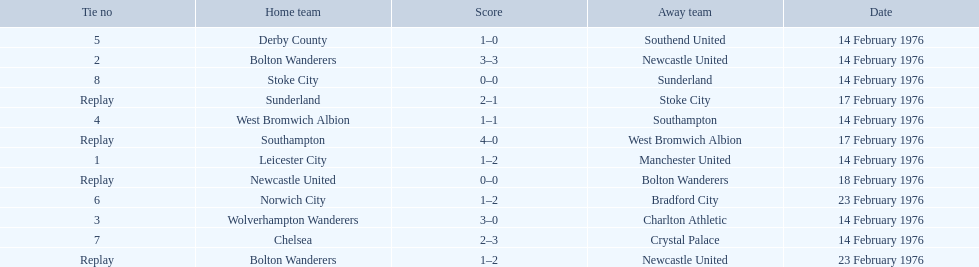What are all of the scores of the 1975-76 fa cup? 1–2, 3–3, 0–0, 1–2, 3–0, 1–1, 4–0, 1–0, 1–2, 2–3, 0–0, 2–1. What are the scores for manchester united or wolverhampton wanderers? 1–2, 3–0. Which has the highest score? 3–0. Who was this score for? Wolverhampton Wanderers. 